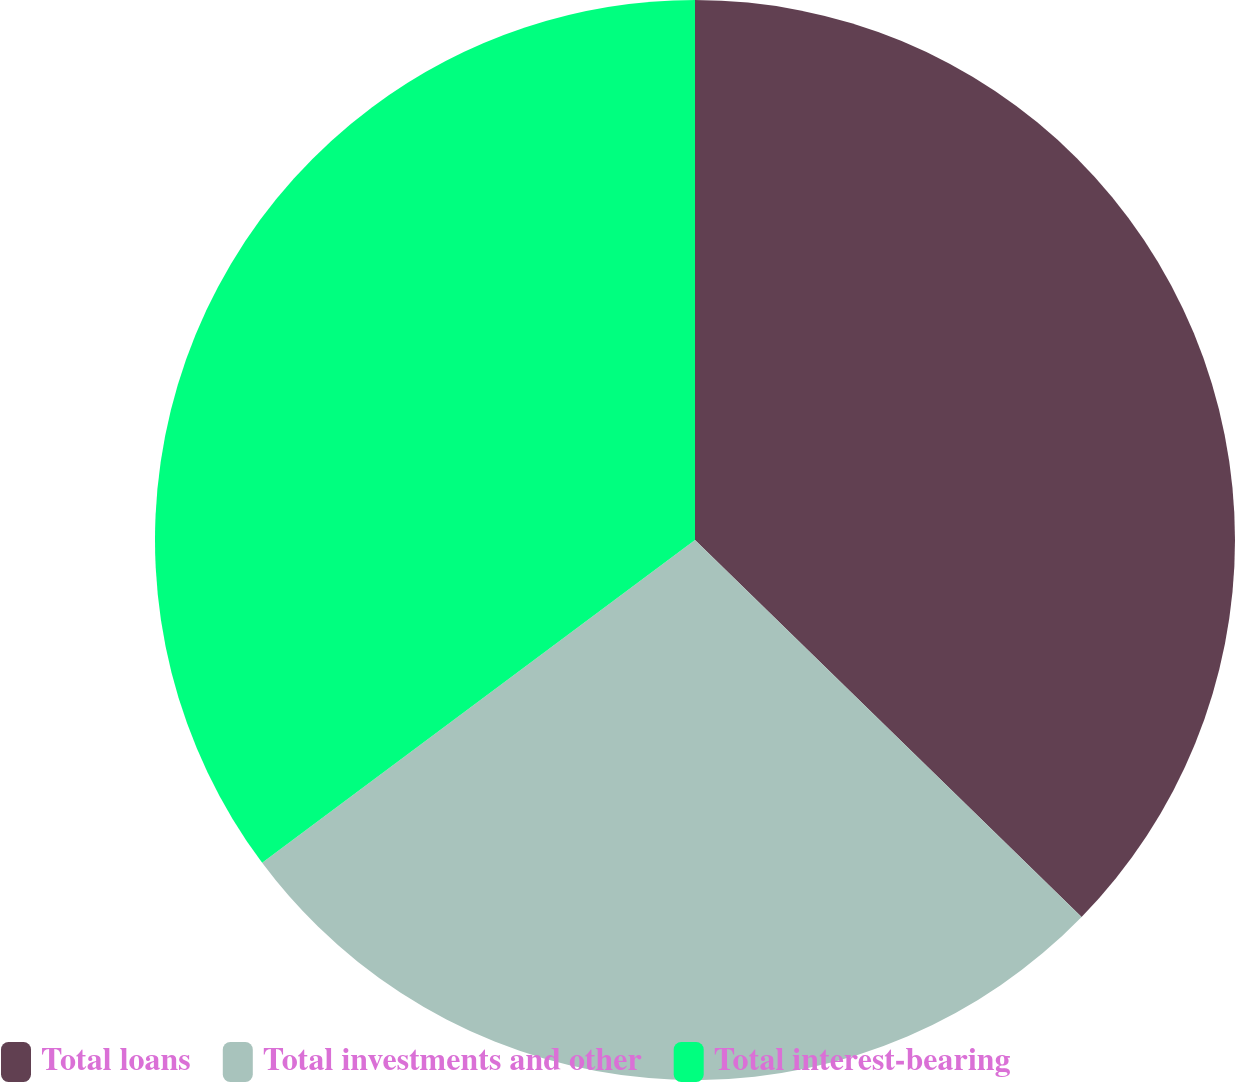Convert chart. <chart><loc_0><loc_0><loc_500><loc_500><pie_chart><fcel>Total loans<fcel>Total investments and other<fcel>Total interest-bearing<nl><fcel>37.3%<fcel>27.5%<fcel>35.2%<nl></chart> 